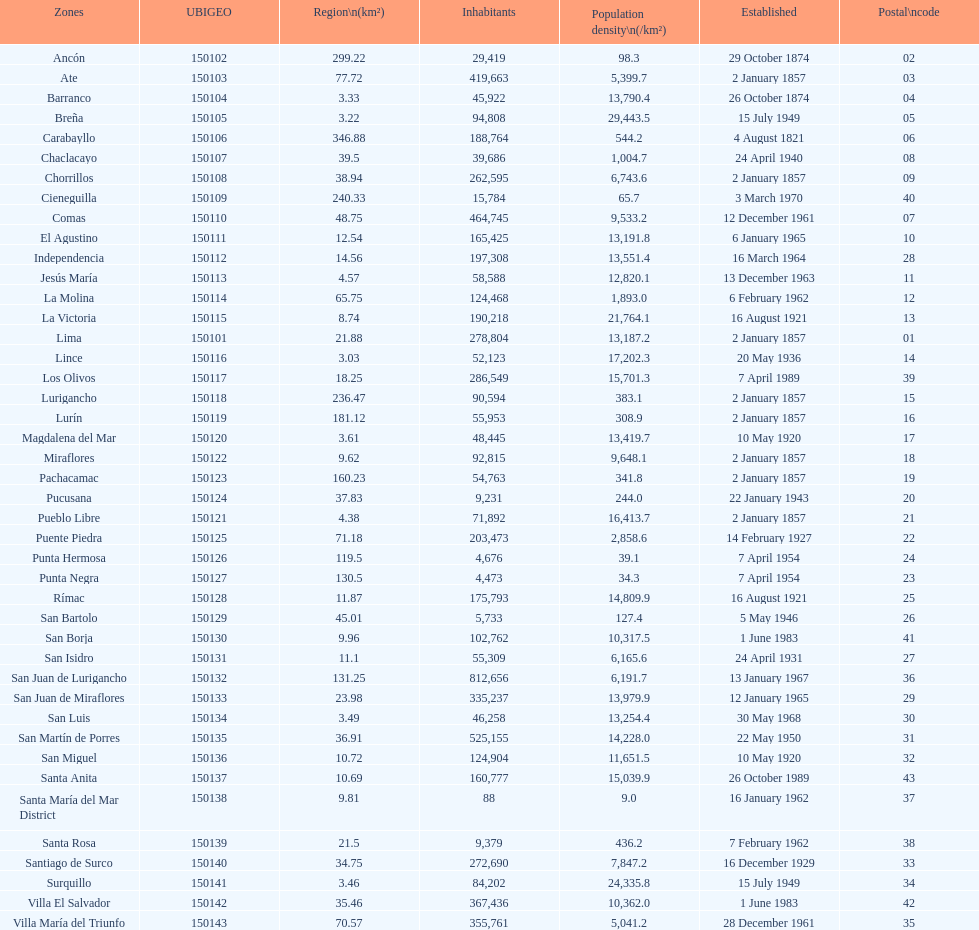How many districts have more than 100,000 people in this city? 21. 